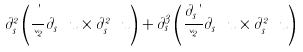Convert formula to latex. <formula><loc_0><loc_0><loc_500><loc_500>\partial _ { s } ^ { 2 } \left ( \frac { \theta } { \kappa ^ { 2 } } \partial _ { s } \ u \times \partial _ { s } ^ { 2 } \ u \right ) + \partial _ { s } ^ { 3 } \left ( \frac { \partial _ { s } \theta } { \kappa ^ { 2 } } \partial _ { s } \ u \times \partial _ { s } ^ { 2 } \ u \right )</formula> 